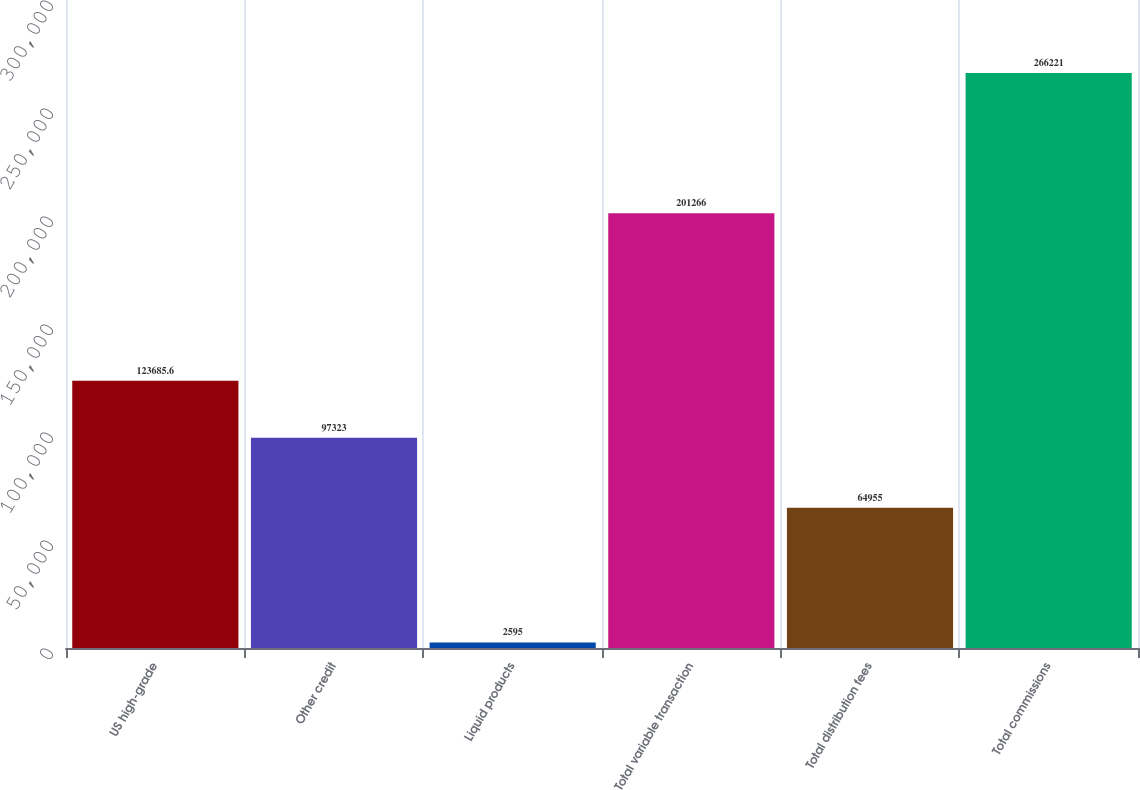<chart> <loc_0><loc_0><loc_500><loc_500><bar_chart><fcel>US high-grade<fcel>Other credit<fcel>Liquid products<fcel>Total variable transaction<fcel>Total distribution fees<fcel>Total commissions<nl><fcel>123686<fcel>97323<fcel>2595<fcel>201266<fcel>64955<fcel>266221<nl></chart> 